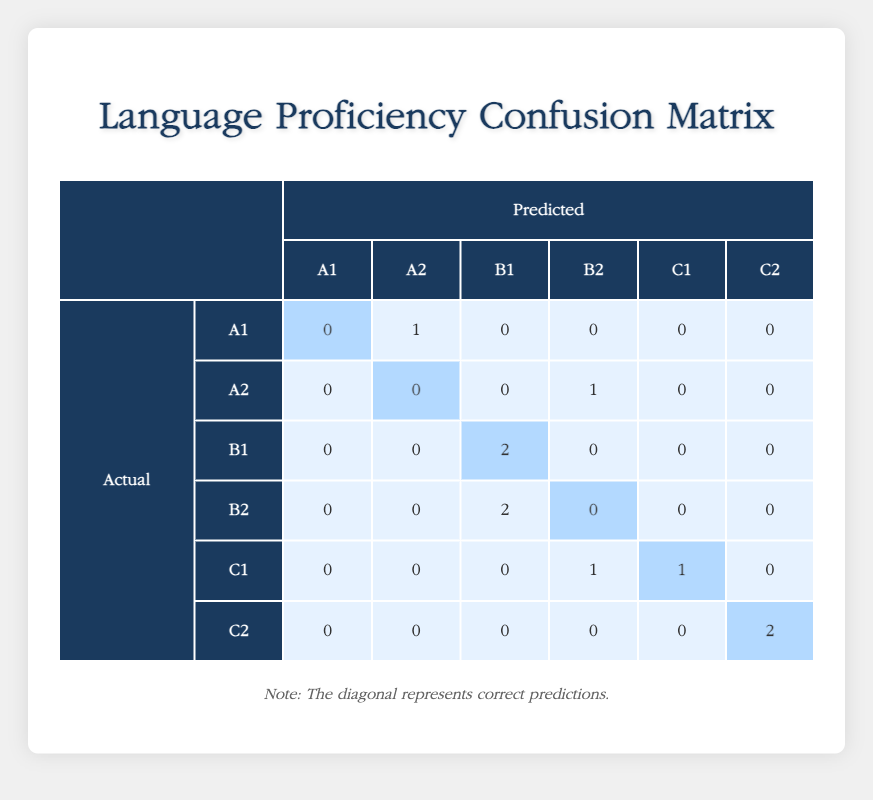What is the predicted proficiency level for student S001? The table shows the row for student S001 under the "Predicted" column, indicating their predicted proficiency level as B1.
Answer: B1 How many students were correctly predicted at the B1 level? Looking at the diagonal values of the confusion matrix, the B1 row indicates that there are 2 correct predictions (2).
Answer: 2 Is there any student who was predicted to have A2 proficiency while the actual proficiency was A1? Checking the A1 row, the predicted proficiency for A1 is 0, meaning no students were predicted to be A2 while actually being A1.
Answer: No What is the total number of students assessed for C2 proficiency? In the C2 row, there are 2 correct predictions (2) and no incorrect predictions; hence, the total number of students assessed for C2 proficiency is 2.
Answer: 2 How many students predicted A2 proficiency actually had B2 proficiency? The table indicates that none of the students were predicted to have A2 proficiency while having B2 proficiency, as the A2 row only shows a prediction of 1 student with actual proficiency B2.
Answer: 0 Among the students who were predicted to have C1 proficiency, how many actually had a lower proficiency level? The row for C1 shows one student predicted to have C1 proficiency who actually had a lower proficiency level (B2), along with one correct prediction for C1, giving us a total of 1 student lower.
Answer: 1 What is the total number of misclassifications across all predicted proficiency levels? Reviewing the confusion matrix, we can sum up all the off-diagonal values, which represent misclassifications: (1+1+2+1) = 5.
Answer: 5 How would you categorize the overall accuracy of the predictions? To determine accuracy, count all correct predictions (on the diagonal: 0+0+2+0+1+2 = 5), and divide by the total predictions (10). The accuracy is therefore 5/10 or 50%.
Answer: 50% 